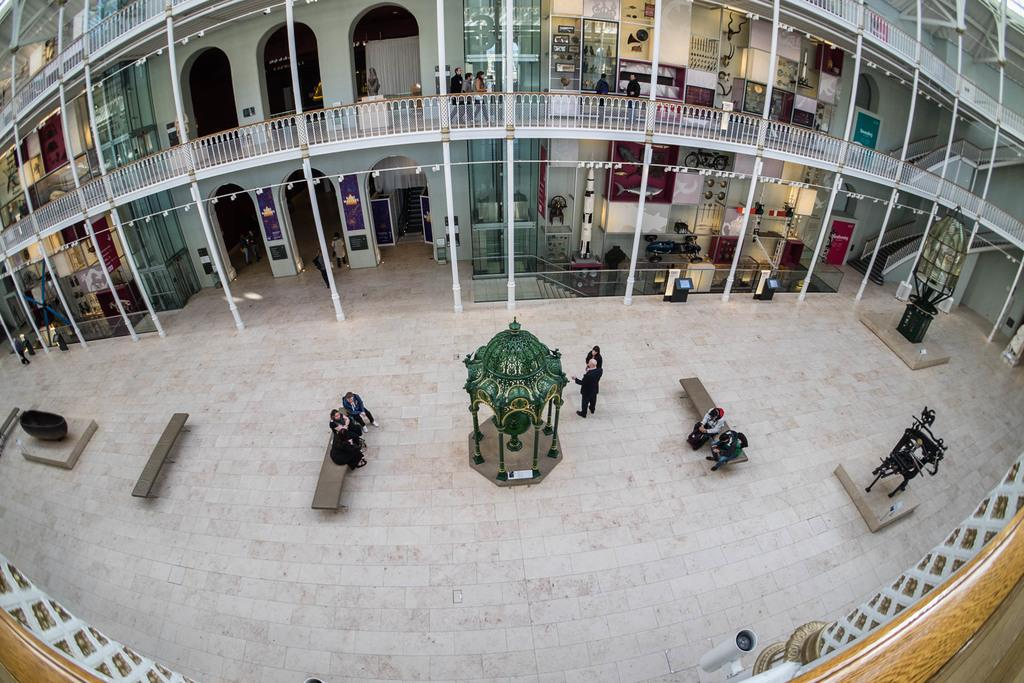What type of location is depicted in the image? The image shows an inside view of a building. Are there any people present in the image? Yes, there are people on the ground in the image. What type of furniture is visible in the image? There are benches in the image. What other objects can be seen in the image? There are poles and some unspecified objects in the image. What type of quilt is draped over the poles in the image? There is no quilt present in the image; only benches, poles, and unspecified objects are visible. How does the sponge contribute to the overall design of the image? There is no sponge present in the image, so it cannot contribute to the overall design. 